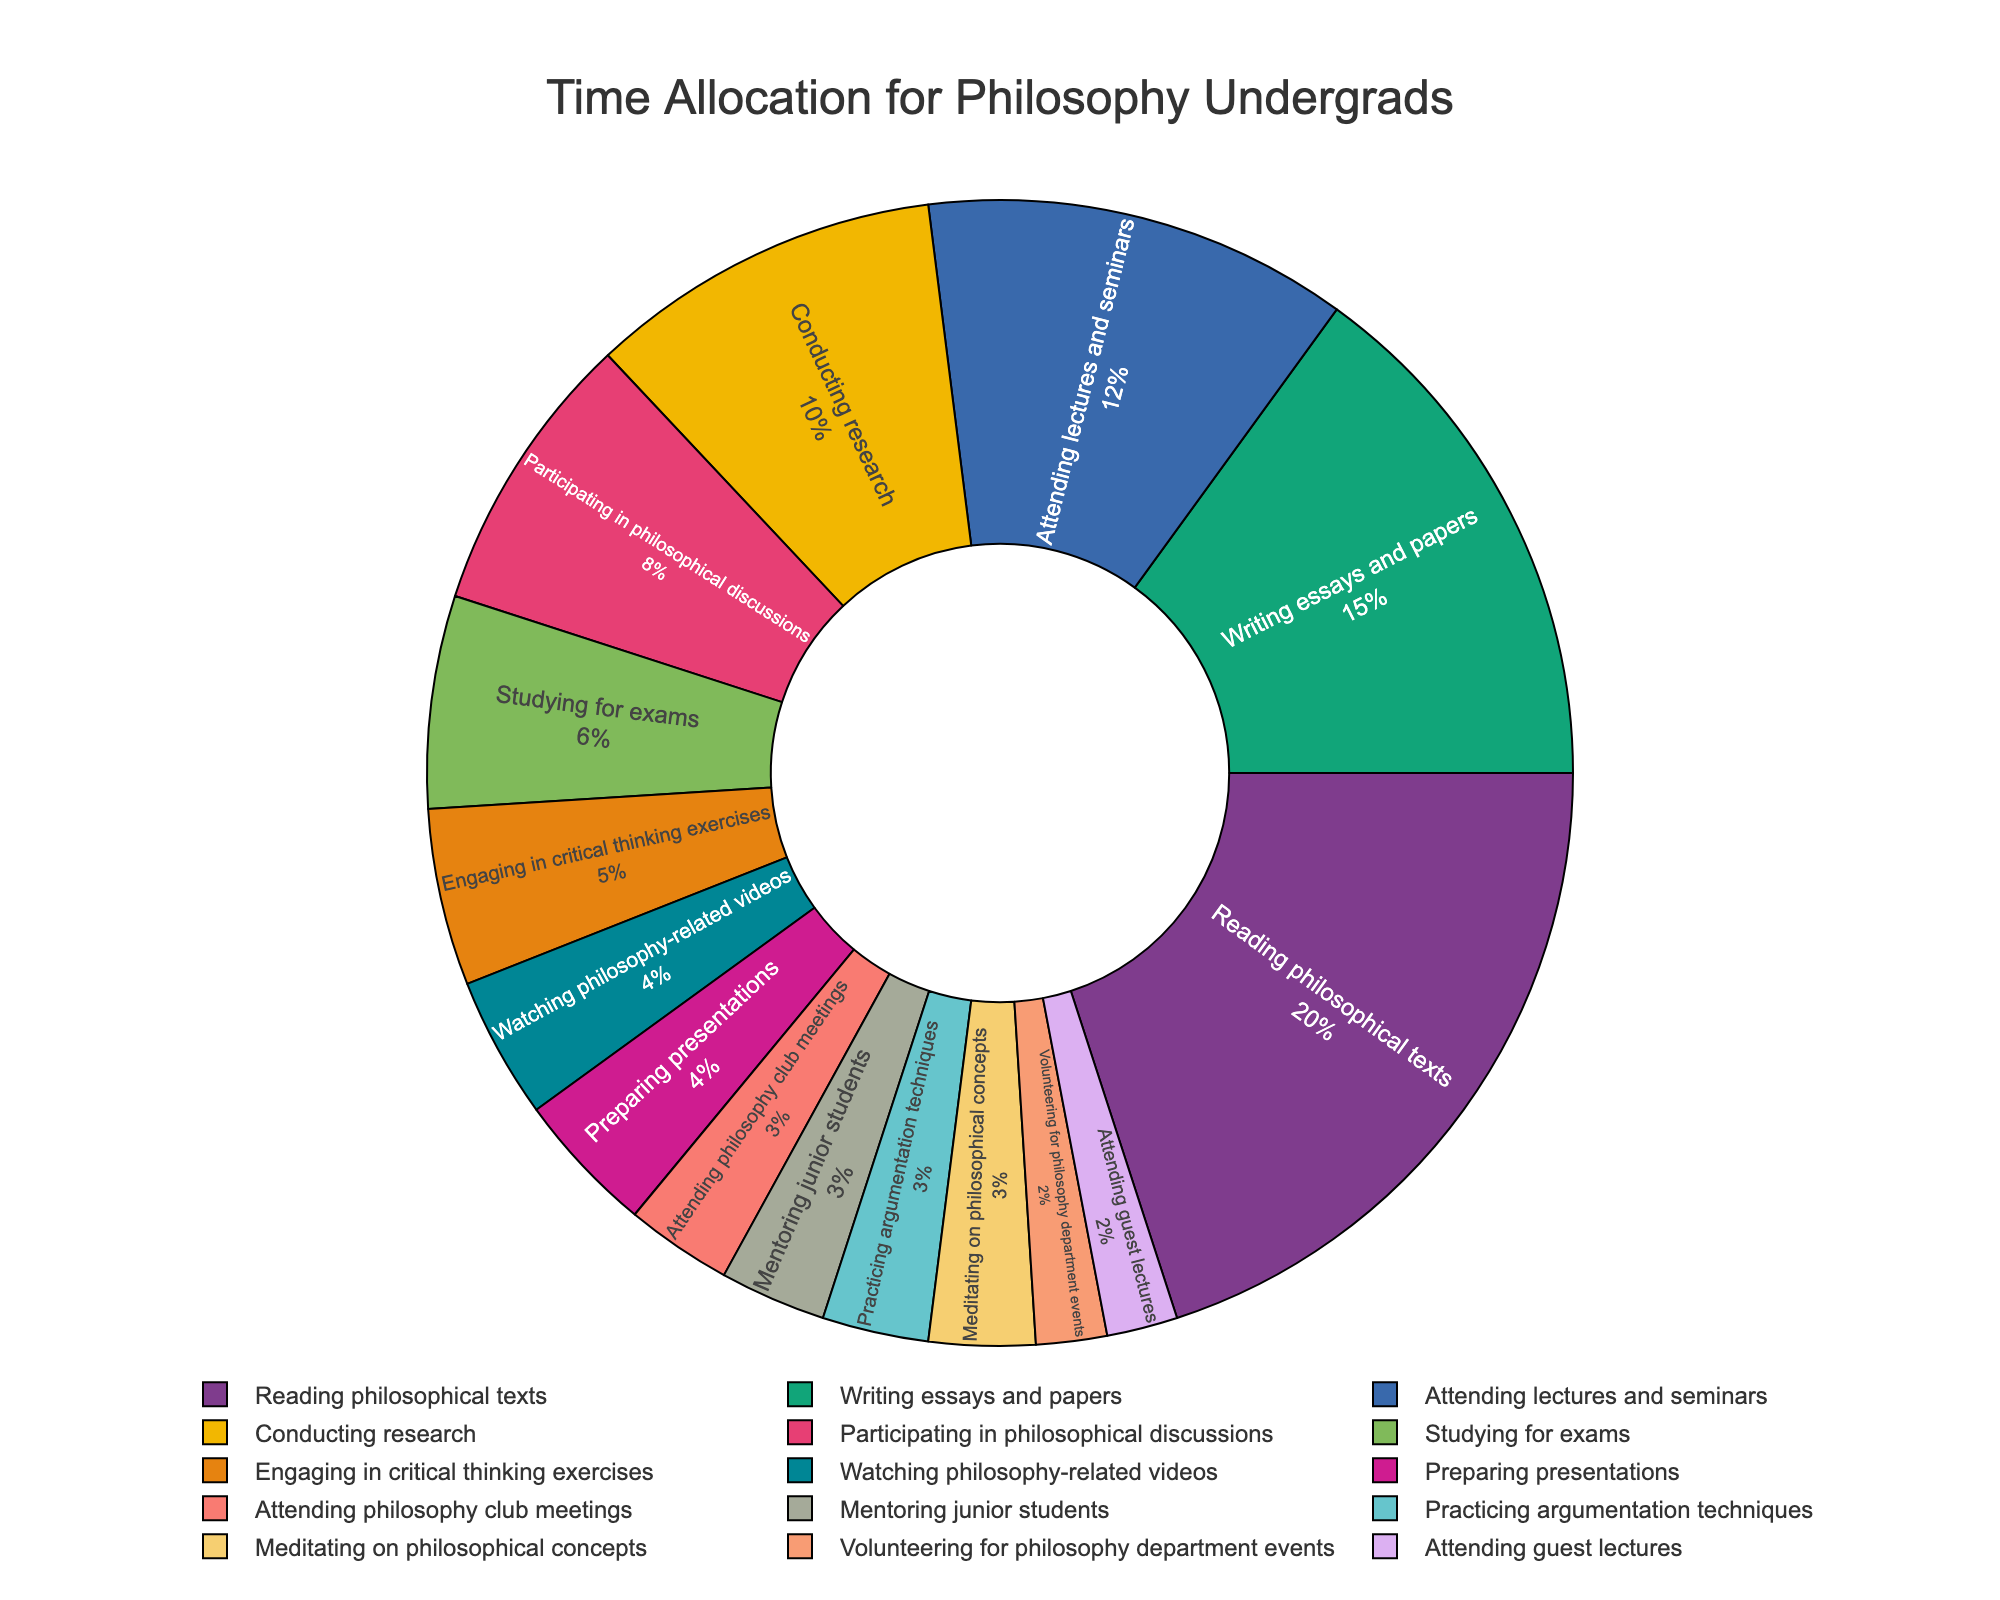What activity do philosophy students spend the most time on? The largest slice of the pie chart represents the activity that occupies the most hours per week.
Answer: Reading philosophical texts Which two activities combined take up more time than writing essays and papers? Writing essays and papers take up 15 hours per week. By examining the pie chart, you will find two activities that together exceed this amount: reading philosophical texts (20 hours) and attending lectures and seminars (12 hours).
Answer: Reading philosophical texts and attending lectures and seminars How much time do students spend on participating in philosophical discussions compared to conducting research? Locate the slices for participating in philosophical discussions and conducting research on the pie chart. Participating in discussions takes 8 hours per week, while conducting research takes 10 hours per week.
Answer: Conducting research takes 2 hours more than participating in discussions What is the color of the section representing studying for exams, and how much time is spent on it? Identify the slice labeled "Studying for exams" and observe its color—then, check the hours allotted to it.
Answer: Green and 6 hours Calculate the total time spent on activities outside of reading, lectures, essays, and research. Sum the hours of all activities except reading philosophical texts (20 hours), attending lectures and seminars (12 hours), writing essays and papers (15 hours), and conducting research (10 hours). The remaining activities sum to (8 + 6 + 3 + 5 + 4 + 2 + 3 + 4 + 2 + 3 + 3 = 43 hours).
Answer: 43 hours What percentage of their time do students spend on less common activities like attending guest lectures, volunteering for department events, and mentoring junior students? Locate and sum the slices for attending guest lectures (2 hours), volunteering (2 hours), and mentoring junior students (3 hours), which equals 7 hours. Then divide by the total hours and convert to a percentage: (7 / 90) * 100 ≈ 7.78%.
Answer: Approximately 7.78% Which activity related to presentations and argumentation takes more time? Compare the slices for preparing presentations (4 hours) and practicing argumentation techniques (3 hours).
Answer: Preparing presentations Combine the time spent on meditation and critical thinking exercises. Does it exceed the time spent on philosophical discussions? Sum the hours for meditating on concepts (3 hours) and engaging in critical thinking exercises (5 hours), then compare to the 8 hours spent on discussions. (3 + 5 = 8, which is equal to the time spent on discussions).
Answer: Equal How does the time spent preparing presentations compare with watching philosophy-related videos? Compare the hours for preparing presentations (4 hours) and watching videos (4 hours).
Answer: They are equal 